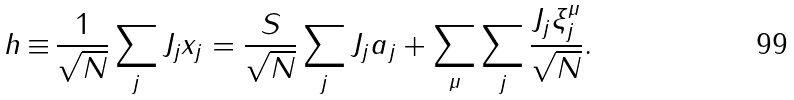Convert formula to latex. <formula><loc_0><loc_0><loc_500><loc_500>h \, { \equiv } \, \frac { 1 } { \sqrt { N } } \sum _ { j } J _ { j } x _ { j } = \frac { S } { \sqrt { N } } \sum _ { j } J _ { j } a _ { j } + \sum _ { \mu } \sum _ { j } \frac { J _ { j } { \xi } _ { j } ^ { \mu } } { \sqrt { N } } .</formula> 